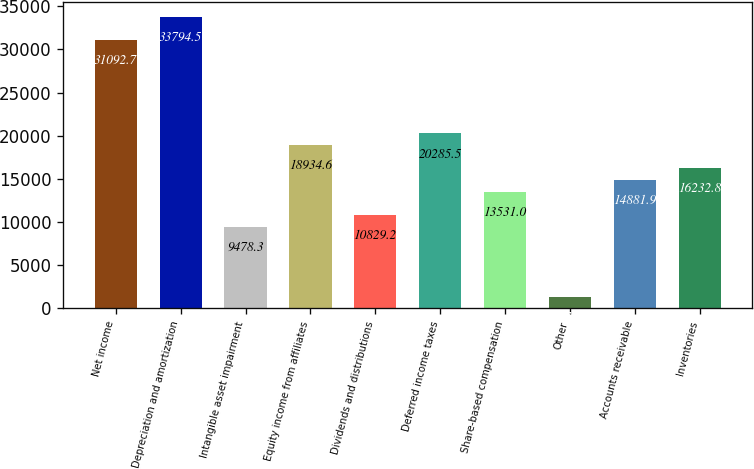Convert chart. <chart><loc_0><loc_0><loc_500><loc_500><bar_chart><fcel>Net income<fcel>Depreciation and amortization<fcel>Intangible asset impairment<fcel>Equity income from affiliates<fcel>Dividends and distributions<fcel>Deferred income taxes<fcel>Share-based compensation<fcel>Other<fcel>Accounts receivable<fcel>Inventories<nl><fcel>31092.7<fcel>33794.5<fcel>9478.3<fcel>18934.6<fcel>10829.2<fcel>20285.5<fcel>13531<fcel>1372.9<fcel>14881.9<fcel>16232.8<nl></chart> 